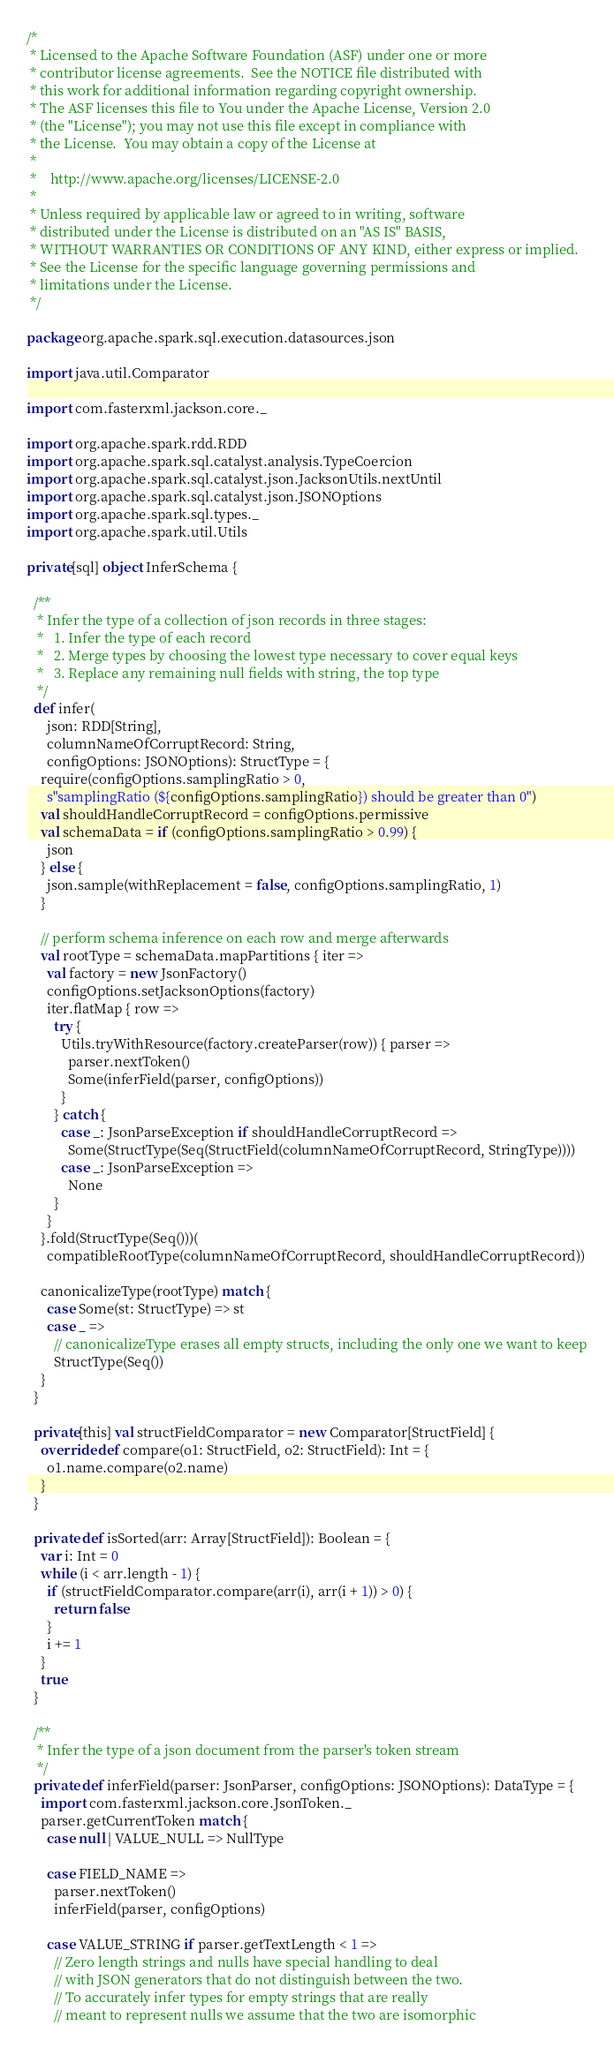<code> <loc_0><loc_0><loc_500><loc_500><_Scala_>/*
 * Licensed to the Apache Software Foundation (ASF) under one or more
 * contributor license agreements.  See the NOTICE file distributed with
 * this work for additional information regarding copyright ownership.
 * The ASF licenses this file to You under the Apache License, Version 2.0
 * (the "License"); you may not use this file except in compliance with
 * the License.  You may obtain a copy of the License at
 *
 *    http://www.apache.org/licenses/LICENSE-2.0
 *
 * Unless required by applicable law or agreed to in writing, software
 * distributed under the License is distributed on an "AS IS" BASIS,
 * WITHOUT WARRANTIES OR CONDITIONS OF ANY KIND, either express or implied.
 * See the License for the specific language governing permissions and
 * limitations under the License.
 */

package org.apache.spark.sql.execution.datasources.json

import java.util.Comparator

import com.fasterxml.jackson.core._

import org.apache.spark.rdd.RDD
import org.apache.spark.sql.catalyst.analysis.TypeCoercion
import org.apache.spark.sql.catalyst.json.JacksonUtils.nextUntil
import org.apache.spark.sql.catalyst.json.JSONOptions
import org.apache.spark.sql.types._
import org.apache.spark.util.Utils

private[sql] object InferSchema {

  /**
   * Infer the type of a collection of json records in three stages:
   *   1. Infer the type of each record
   *   2. Merge types by choosing the lowest type necessary to cover equal keys
   *   3. Replace any remaining null fields with string, the top type
   */
  def infer(
      json: RDD[String],
      columnNameOfCorruptRecord: String,
      configOptions: JSONOptions): StructType = {
    require(configOptions.samplingRatio > 0,
      s"samplingRatio (${configOptions.samplingRatio}) should be greater than 0")
    val shouldHandleCorruptRecord = configOptions.permissive
    val schemaData = if (configOptions.samplingRatio > 0.99) {
      json
    } else {
      json.sample(withReplacement = false, configOptions.samplingRatio, 1)
    }

    // perform schema inference on each row and merge afterwards
    val rootType = schemaData.mapPartitions { iter =>
      val factory = new JsonFactory()
      configOptions.setJacksonOptions(factory)
      iter.flatMap { row =>
        try {
          Utils.tryWithResource(factory.createParser(row)) { parser =>
            parser.nextToken()
            Some(inferField(parser, configOptions))
          }
        } catch {
          case _: JsonParseException if shouldHandleCorruptRecord =>
            Some(StructType(Seq(StructField(columnNameOfCorruptRecord, StringType))))
          case _: JsonParseException =>
            None
        }
      }
    }.fold(StructType(Seq()))(
      compatibleRootType(columnNameOfCorruptRecord, shouldHandleCorruptRecord))

    canonicalizeType(rootType) match {
      case Some(st: StructType) => st
      case _ =>
        // canonicalizeType erases all empty structs, including the only one we want to keep
        StructType(Seq())
    }
  }

  private[this] val structFieldComparator = new Comparator[StructField] {
    override def compare(o1: StructField, o2: StructField): Int = {
      o1.name.compare(o2.name)
    }
  }

  private def isSorted(arr: Array[StructField]): Boolean = {
    var i: Int = 0
    while (i < arr.length - 1) {
      if (structFieldComparator.compare(arr(i), arr(i + 1)) > 0) {
        return false
      }
      i += 1
    }
    true
  }

  /**
   * Infer the type of a json document from the parser's token stream
   */
  private def inferField(parser: JsonParser, configOptions: JSONOptions): DataType = {
    import com.fasterxml.jackson.core.JsonToken._
    parser.getCurrentToken match {
      case null | VALUE_NULL => NullType

      case FIELD_NAME =>
        parser.nextToken()
        inferField(parser, configOptions)

      case VALUE_STRING if parser.getTextLength < 1 =>
        // Zero length strings and nulls have special handling to deal
        // with JSON generators that do not distinguish between the two.
        // To accurately infer types for empty strings that are really
        // meant to represent nulls we assume that the two are isomorphic</code> 